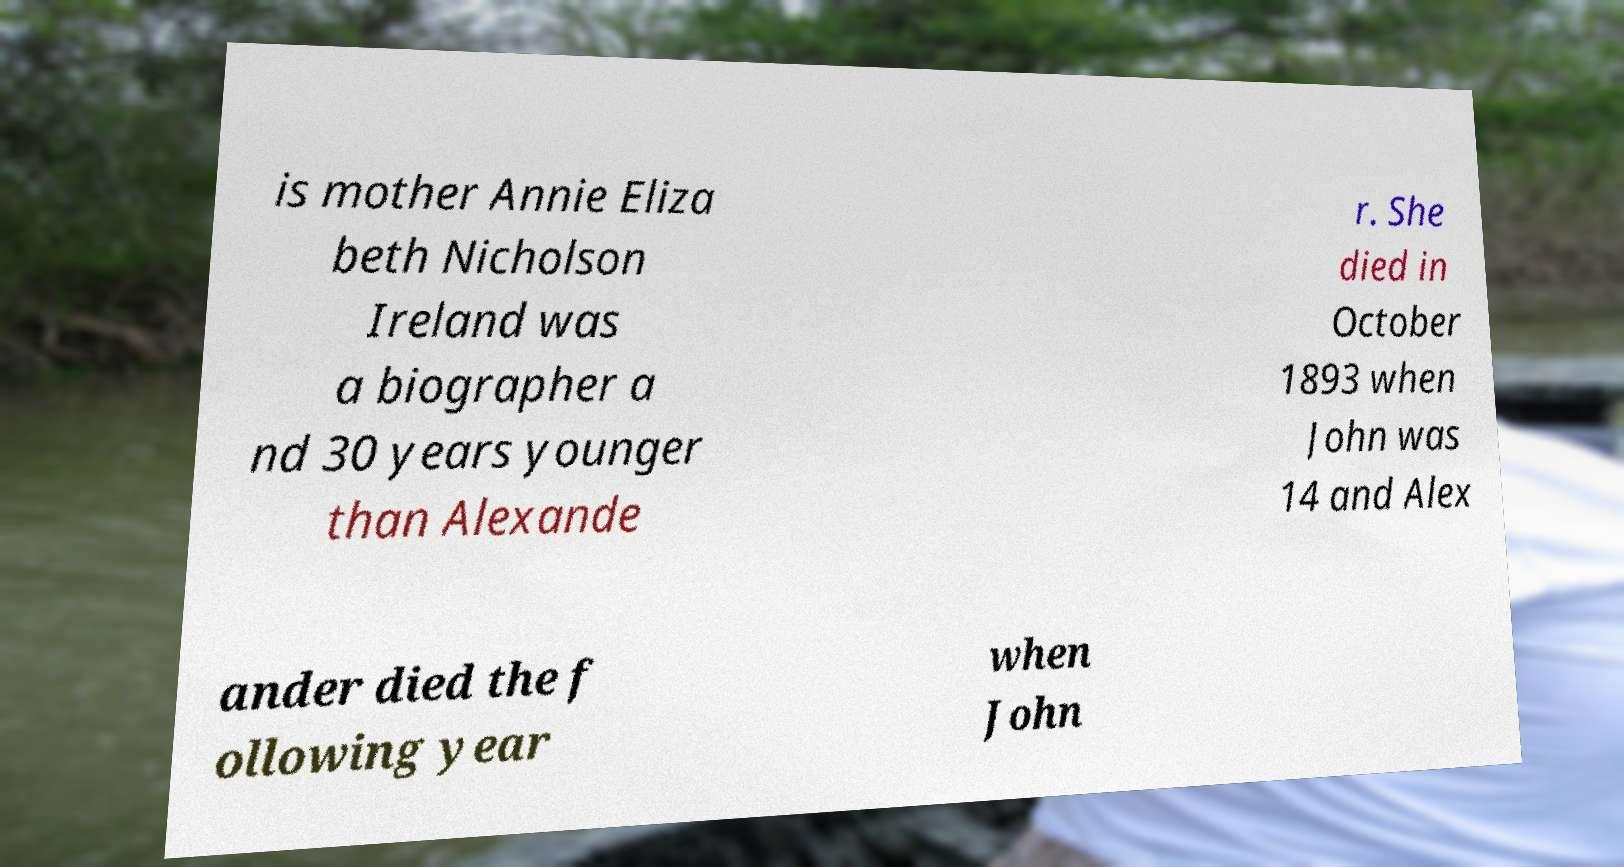For documentation purposes, I need the text within this image transcribed. Could you provide that? is mother Annie Eliza beth Nicholson Ireland was a biographer a nd 30 years younger than Alexande r. She died in October 1893 when John was 14 and Alex ander died the f ollowing year when John 